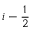<formula> <loc_0><loc_0><loc_500><loc_500>i - \frac { 1 } { 2 }</formula> 